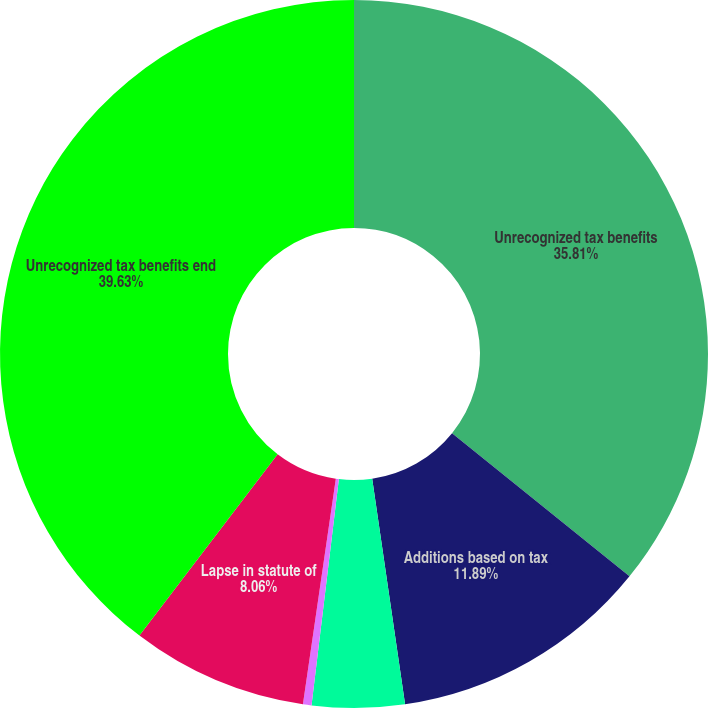Convert chart. <chart><loc_0><loc_0><loc_500><loc_500><pie_chart><fcel>Unrecognized tax benefits<fcel>Additions based on tax<fcel>Additions for tax positions of<fcel>Reductions for tax positions<fcel>Lapse in statute of<fcel>Unrecognized tax benefits end<nl><fcel>35.81%<fcel>11.89%<fcel>4.22%<fcel>0.39%<fcel>8.06%<fcel>39.64%<nl></chart> 